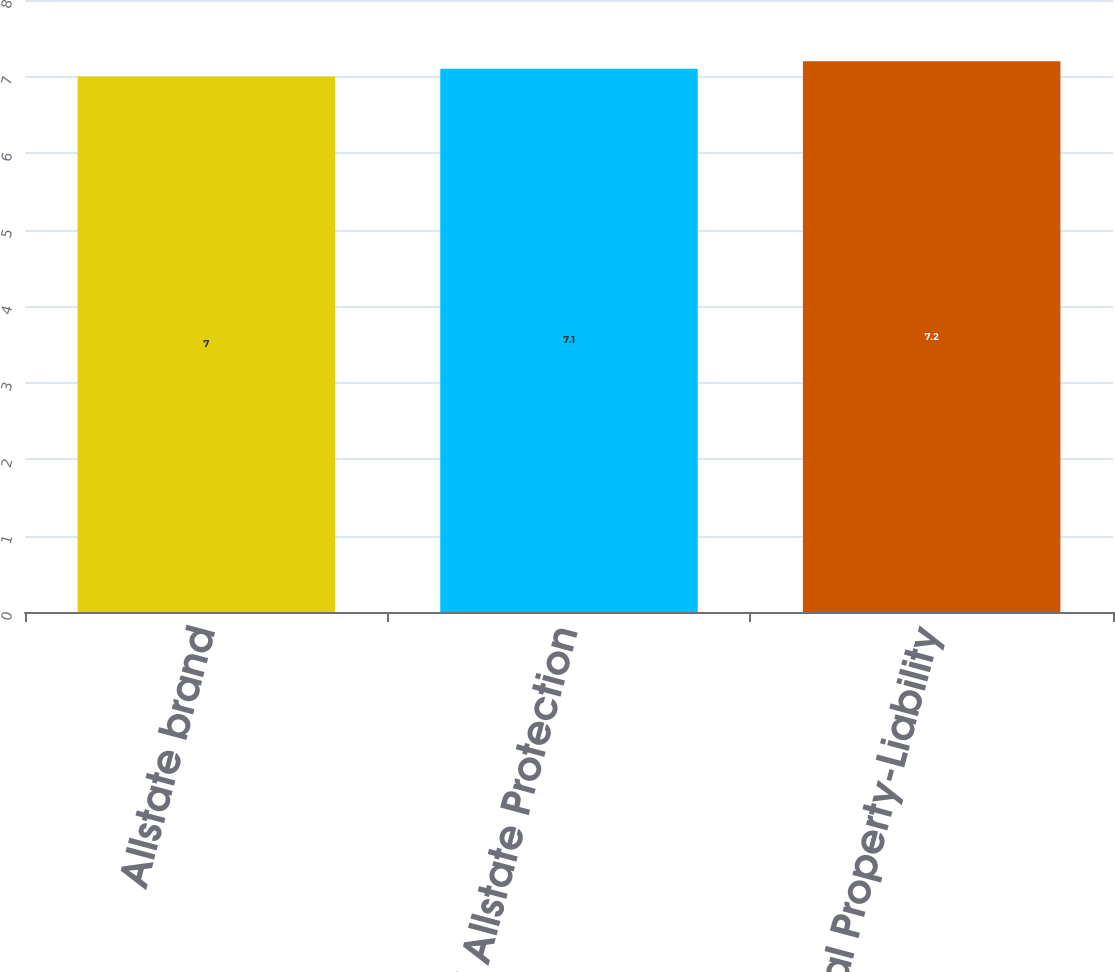Convert chart. <chart><loc_0><loc_0><loc_500><loc_500><bar_chart><fcel>Allstate brand<fcel>Total Allstate Protection<fcel>Total Property-Liability<nl><fcel>7<fcel>7.1<fcel>7.2<nl></chart> 